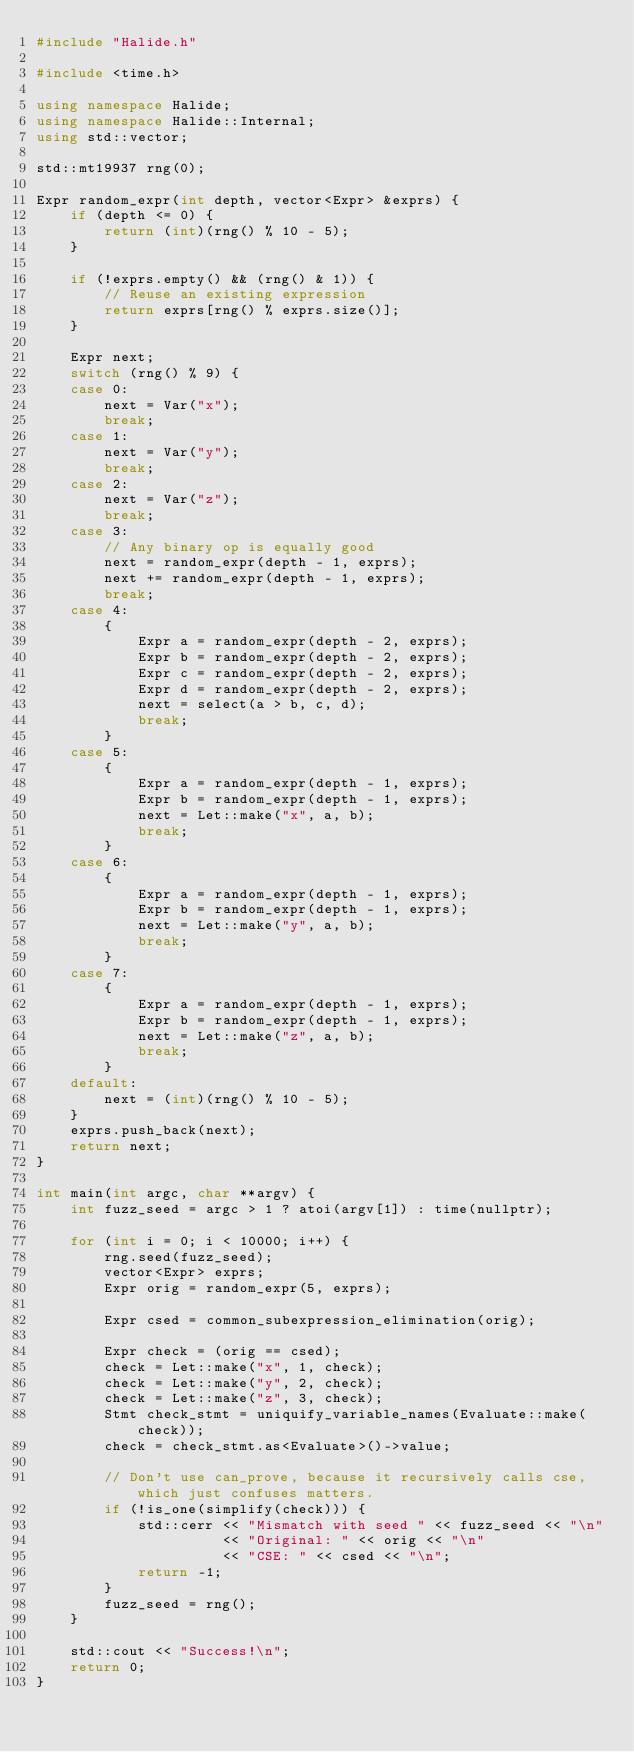Convert code to text. <code><loc_0><loc_0><loc_500><loc_500><_C++_>#include "Halide.h"

#include <time.h>

using namespace Halide;
using namespace Halide::Internal;
using std::vector;

std::mt19937 rng(0);

Expr random_expr(int depth, vector<Expr> &exprs) {
    if (depth <= 0) {
        return (int)(rng() % 10 - 5);
    }

    if (!exprs.empty() && (rng() & 1)) {
        // Reuse an existing expression
        return exprs[rng() % exprs.size()];
    }

    Expr next;
    switch (rng() % 9) {
    case 0:
        next = Var("x");
        break;
    case 1:
        next = Var("y");
        break;
    case 2:
        next = Var("z");
        break;
    case 3:
        // Any binary op is equally good
        next = random_expr(depth - 1, exprs);
        next += random_expr(depth - 1, exprs);
        break;
    case 4:
        {
            Expr a = random_expr(depth - 2, exprs);
            Expr b = random_expr(depth - 2, exprs);
            Expr c = random_expr(depth - 2, exprs);
            Expr d = random_expr(depth - 2, exprs);
            next = select(a > b, c, d);
            break;
        }
    case 5:
        {
            Expr a = random_expr(depth - 1, exprs);
            Expr b = random_expr(depth - 1, exprs);
            next = Let::make("x", a, b);
            break;
        }
    case 6:
        {
            Expr a = random_expr(depth - 1, exprs);
            Expr b = random_expr(depth - 1, exprs);
            next = Let::make("y", a, b);
            break;
        }
    case 7:
        {
            Expr a = random_expr(depth - 1, exprs);
            Expr b = random_expr(depth - 1, exprs);
            next = Let::make("z", a, b);
            break;
        }
    default:
        next = (int)(rng() % 10 - 5);
    }
    exprs.push_back(next);
    return next;
}

int main(int argc, char **argv) {
    int fuzz_seed = argc > 1 ? atoi(argv[1]) : time(nullptr);

    for (int i = 0; i < 10000; i++) {
        rng.seed(fuzz_seed);
        vector<Expr> exprs;
        Expr orig = random_expr(5, exprs);

        Expr csed = common_subexpression_elimination(orig);

        Expr check = (orig == csed);
        check = Let::make("x", 1, check);
        check = Let::make("y", 2, check);
        check = Let::make("z", 3, check);
        Stmt check_stmt = uniquify_variable_names(Evaluate::make(check));
        check = check_stmt.as<Evaluate>()->value;

        // Don't use can_prove, because it recursively calls cse, which just confuses matters.
        if (!is_one(simplify(check))) {
            std::cerr << "Mismatch with seed " << fuzz_seed << "\n"
                      << "Original: " << orig << "\n"
                      << "CSE: " << csed << "\n";
            return -1;
        }
        fuzz_seed = rng();
    }

    std::cout << "Success!\n";
    return 0;
}
</code> 